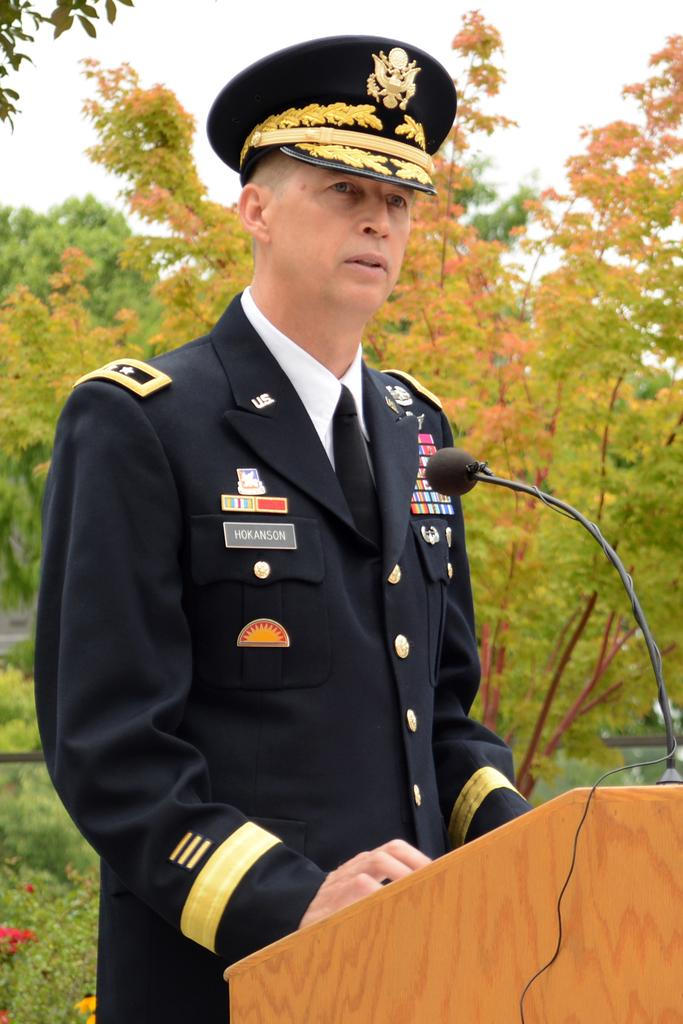Who is the main subject in the image? There is a person in the image. What is the person doing in the image? The person is standing and talking. What object is the person interacting with in the image? The person is in front of a microphone. What type of cabbage is being served for lunch in the image? There is no mention of lunch or cabbage in the image; it features a person standing in front of a microphone while talking. 